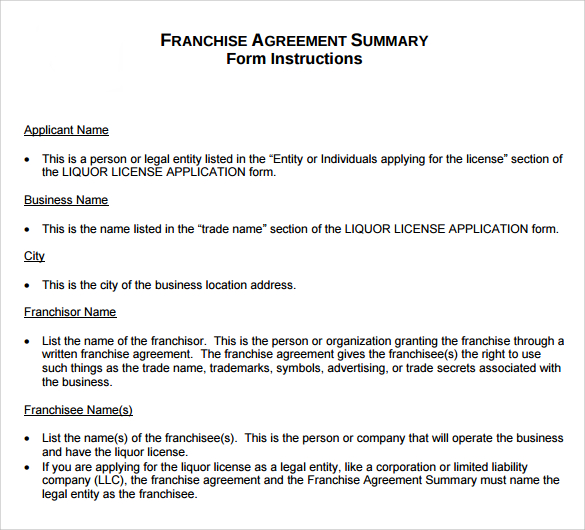Who determines the franchisee's ability to retain a liquor license and what might influence this decision? The ability of the franchisee to retain a liquor license is determined by local licensing authorities or governing bodies that manage liquor laws. Factors influencing this decision include the franchisee’s adherence to local laws and regulations, the record of any previous violations, and the overall management of the outlets selling liquor. Regular inspections and compliance audits also play a major role in determining whether the franchisee can retain the license. 